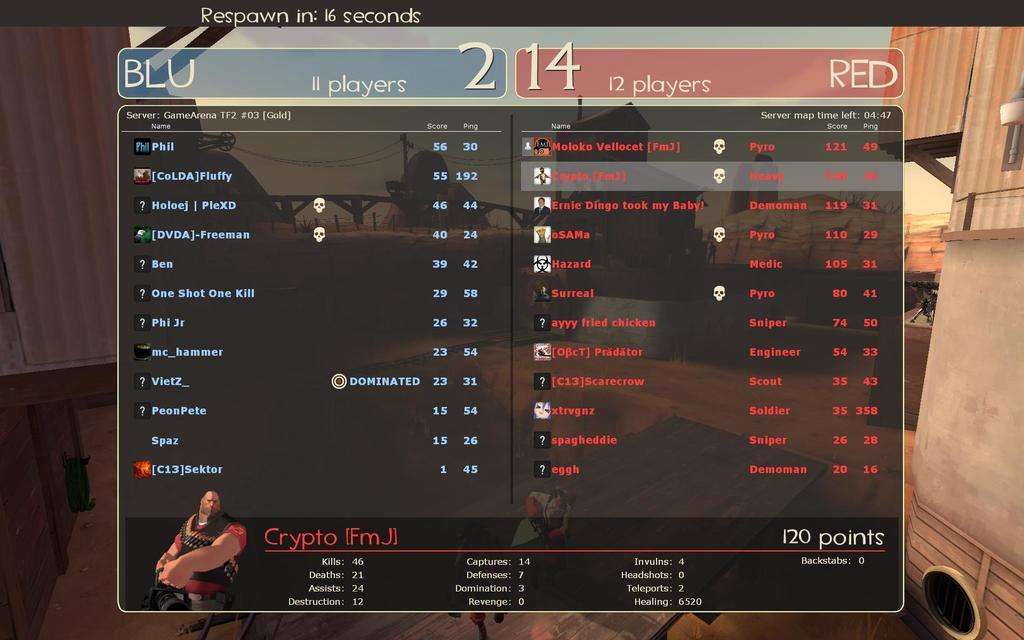<image>
Provide a brief description of the given image. The screen says that the Blu team has 11 players and the Red team has 12 players. 